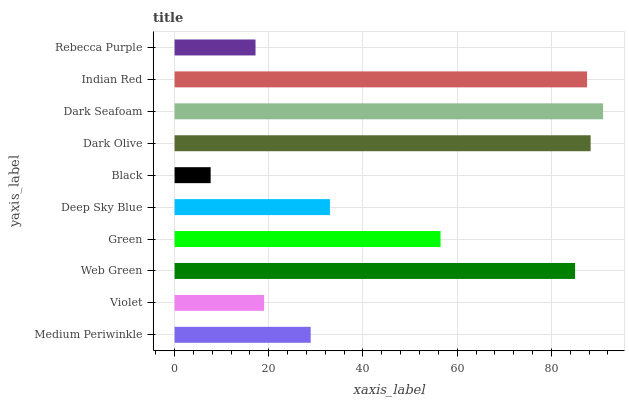Is Black the minimum?
Answer yes or no. Yes. Is Dark Seafoam the maximum?
Answer yes or no. Yes. Is Violet the minimum?
Answer yes or no. No. Is Violet the maximum?
Answer yes or no. No. Is Medium Periwinkle greater than Violet?
Answer yes or no. Yes. Is Violet less than Medium Periwinkle?
Answer yes or no. Yes. Is Violet greater than Medium Periwinkle?
Answer yes or no. No. Is Medium Periwinkle less than Violet?
Answer yes or no. No. Is Green the high median?
Answer yes or no. Yes. Is Deep Sky Blue the low median?
Answer yes or no. Yes. Is Dark Seafoam the high median?
Answer yes or no. No. Is Web Green the low median?
Answer yes or no. No. 